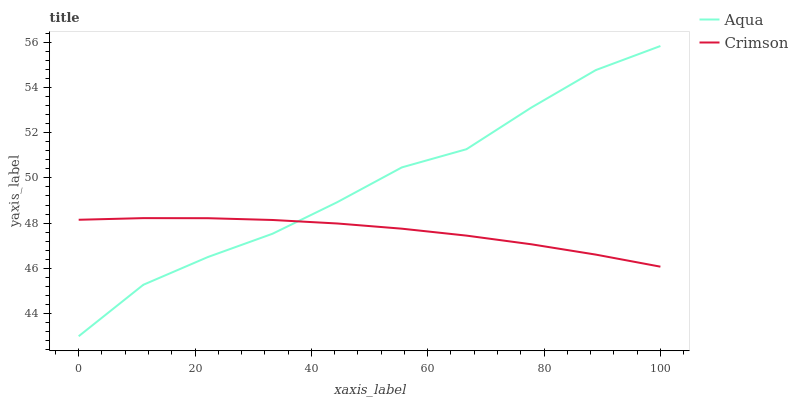Does Crimson have the minimum area under the curve?
Answer yes or no. Yes. Does Aqua have the maximum area under the curve?
Answer yes or no. Yes. Does Aqua have the minimum area under the curve?
Answer yes or no. No. Is Crimson the smoothest?
Answer yes or no. Yes. Is Aqua the roughest?
Answer yes or no. Yes. Is Aqua the smoothest?
Answer yes or no. No. Does Aqua have the lowest value?
Answer yes or no. Yes. Does Aqua have the highest value?
Answer yes or no. Yes. Does Aqua intersect Crimson?
Answer yes or no. Yes. Is Aqua less than Crimson?
Answer yes or no. No. Is Aqua greater than Crimson?
Answer yes or no. No. 